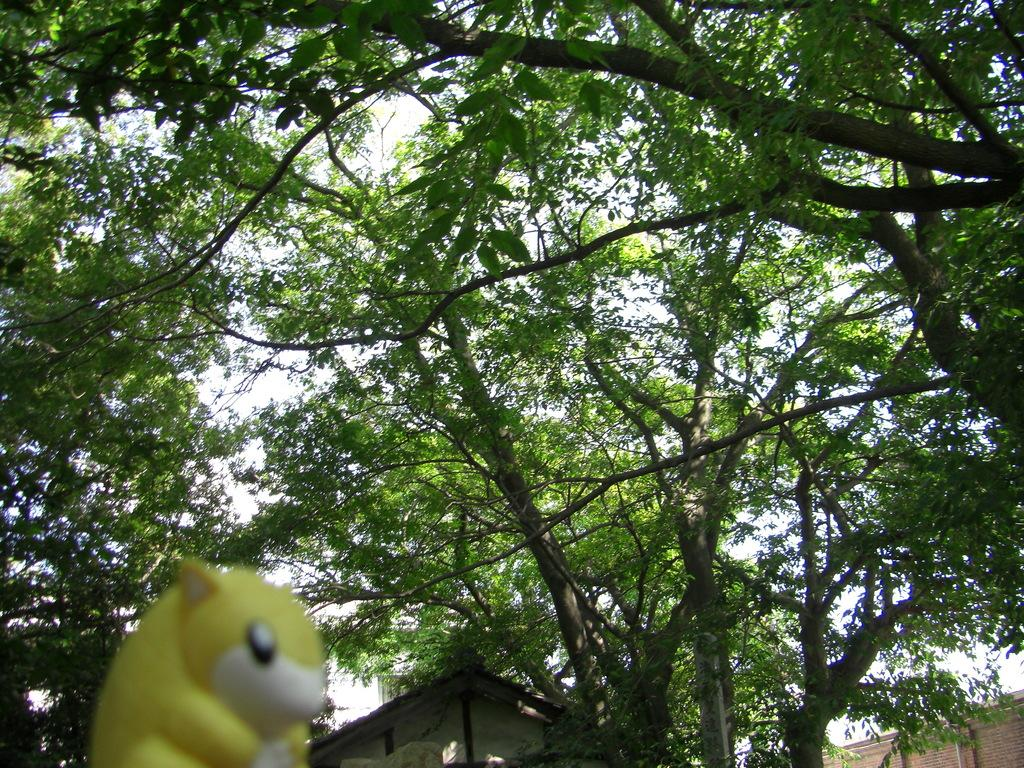What type of toy is present in the image? There is a toy in the shape of a squirrel in the image. What can be seen in the background of the image? There is a house and trees in the background of the image. What is visible in the sky in the image? The sky is visible in the background of the image. What type of harmony can be heard in the image? There is no sound or music present in the image, so it is not possible to determine the type of harmony. 